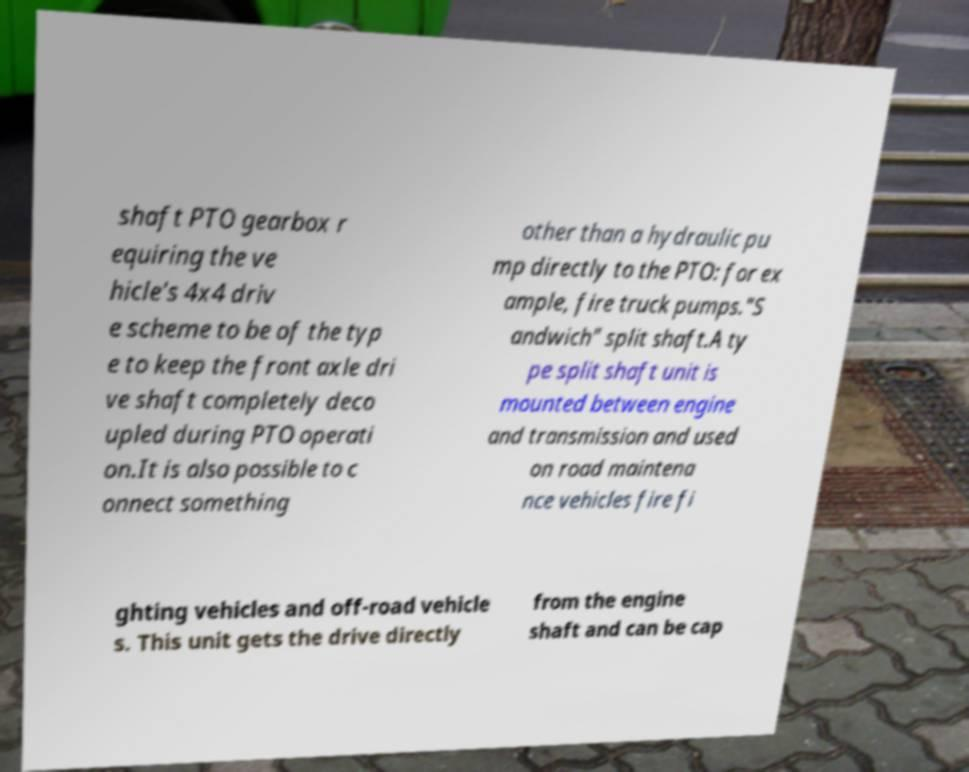Could you extract and type out the text from this image? shaft PTO gearbox r equiring the ve hicle's 4x4 driv e scheme to be of the typ e to keep the front axle dri ve shaft completely deco upled during PTO operati on.It is also possible to c onnect something other than a hydraulic pu mp directly to the PTO: for ex ample, fire truck pumps."S andwich" split shaft.A ty pe split shaft unit is mounted between engine and transmission and used on road maintena nce vehicles fire fi ghting vehicles and off-road vehicle s. This unit gets the drive directly from the engine shaft and can be cap 